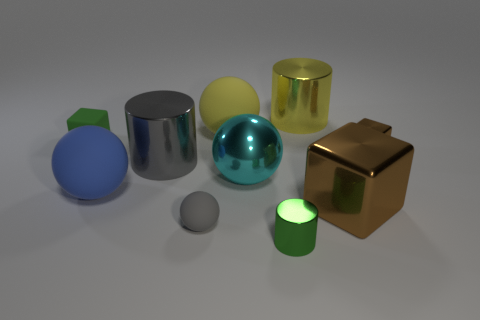What number of other objects are the same material as the small green cylinder?
Your answer should be very brief. 5. What color is the sphere behind the small brown metal thing?
Make the answer very short. Yellow. There is a large sphere left of the matte object behind the tiny green thing to the left of the small green metal cylinder; what is its material?
Keep it short and to the point. Rubber. Are there any other big yellow objects of the same shape as the yellow rubber thing?
Give a very brief answer. No. The green rubber object that is the same size as the gray matte object is what shape?
Your answer should be compact. Cube. What number of big things are both on the left side of the gray rubber sphere and on the right side of the large blue rubber thing?
Offer a very short reply. 1. Are there fewer gray objects in front of the large metallic sphere than small gray spheres?
Ensure brevity in your answer.  No. Are there any cyan things of the same size as the yellow shiny cylinder?
Keep it short and to the point. Yes. There is a tiny cube that is the same material as the small sphere; what color is it?
Provide a succinct answer. Green. There is a tiny matte object right of the small green block; how many metallic objects are to the right of it?
Make the answer very short. 5. 